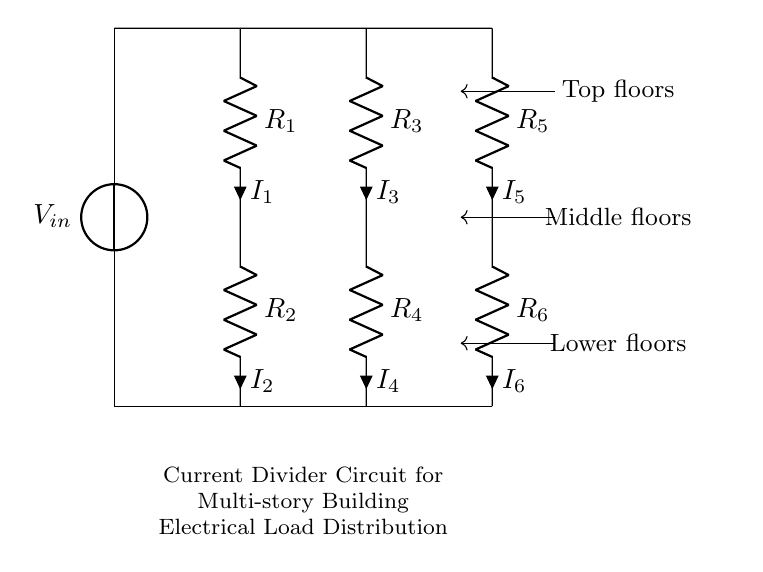What is the input voltage of this circuit? The input voltage, labeled as V_in, can be identified directly from the voltage source symbol in the circuit diagram.
Answer: V_in How many resistors are in this circuit? By counting the resistor symbols in the diagram, there are six resistors labeled R_1 to R_6.
Answer: Six Which resistor has the highest position in the diagram? The highest resistor in the circuit diagram is R_1, as it is positioned at the topmost segment and connected directly to V_in.
Answer: R_1 What is the role of the current divider in this circuit? The current divider function is to split the input current I into various branches according to the values of the resistors, allowing for controlled load distribution among different sections of the building's electrical system.
Answer: Distributing current What is the relationship between the currents in parallel resistors? The currents I_1, I_2, and I_3 split from the input voltage, where the current flowing through each resistor is inversely proportional to its resistance value, as per Ohm's law and the principles of parallel circuits.
Answer: Inverse proportionality What floors does this circuit represent? The labels in the circuit indicate that the designated current paths correspond to the top floors, middle floors, and lower floors of a multi-story building.
Answer: Top, middle, lower 